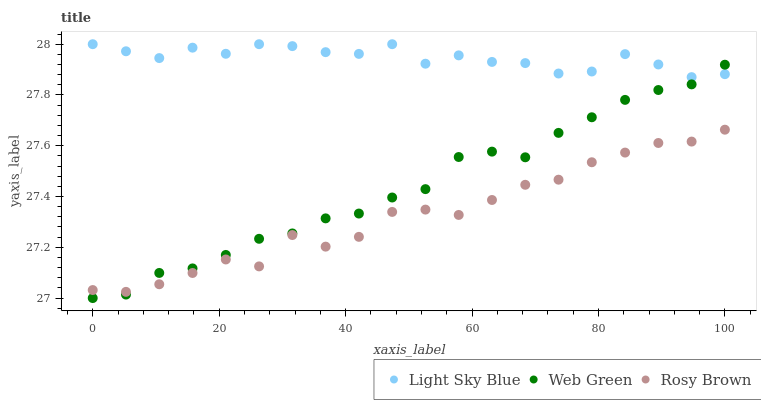Does Rosy Brown have the minimum area under the curve?
Answer yes or no. Yes. Does Light Sky Blue have the maximum area under the curve?
Answer yes or no. Yes. Does Web Green have the minimum area under the curve?
Answer yes or no. No. Does Web Green have the maximum area under the curve?
Answer yes or no. No. Is Web Green the smoothest?
Answer yes or no. Yes. Is Rosy Brown the roughest?
Answer yes or no. Yes. Is Light Sky Blue the smoothest?
Answer yes or no. No. Is Light Sky Blue the roughest?
Answer yes or no. No. Does Web Green have the lowest value?
Answer yes or no. Yes. Does Light Sky Blue have the lowest value?
Answer yes or no. No. Does Light Sky Blue have the highest value?
Answer yes or no. Yes. Does Web Green have the highest value?
Answer yes or no. No. Is Rosy Brown less than Light Sky Blue?
Answer yes or no. Yes. Is Light Sky Blue greater than Rosy Brown?
Answer yes or no. Yes. Does Web Green intersect Rosy Brown?
Answer yes or no. Yes. Is Web Green less than Rosy Brown?
Answer yes or no. No. Is Web Green greater than Rosy Brown?
Answer yes or no. No. Does Rosy Brown intersect Light Sky Blue?
Answer yes or no. No. 